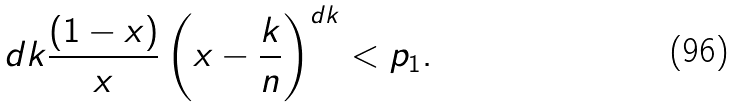<formula> <loc_0><loc_0><loc_500><loc_500>d k \frac { \left ( 1 - x \right ) } { x } \left ( x - \frac { k } { n } \right ) ^ { d k } < p _ { 1 } .</formula> 